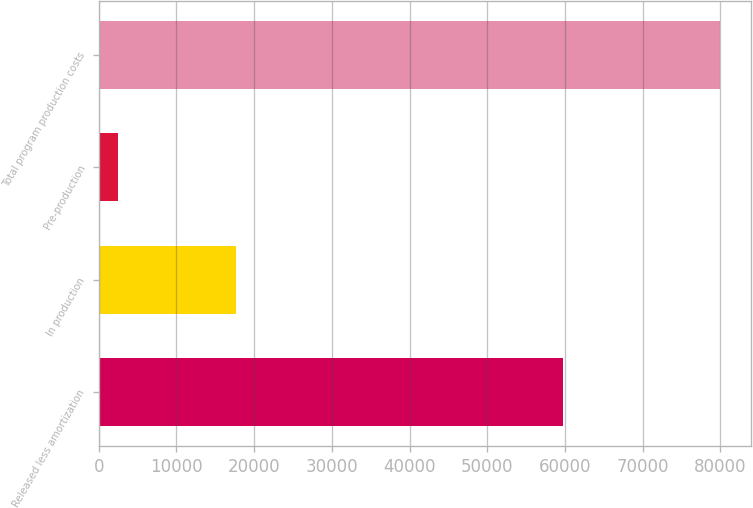<chart> <loc_0><loc_0><loc_500><loc_500><bar_chart><fcel>Released less amortization<fcel>In production<fcel>Pre-production<fcel>Total program production costs<nl><fcel>59783<fcel>17683<fcel>2499<fcel>79965<nl></chart> 